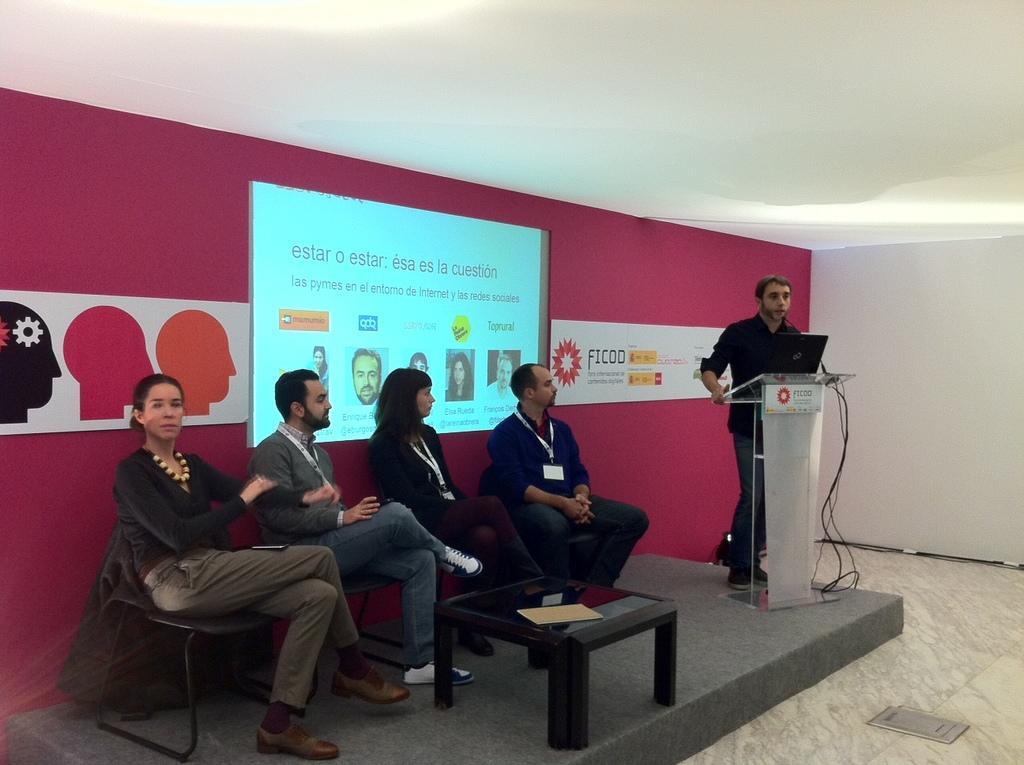Can you describe this image briefly? In the center of the image, we can see people sitting on chairs and wearing id cards and on the right, there is a person standing in front of podium, we can see a table on the stage. In the background, there is a screen and a wall. 